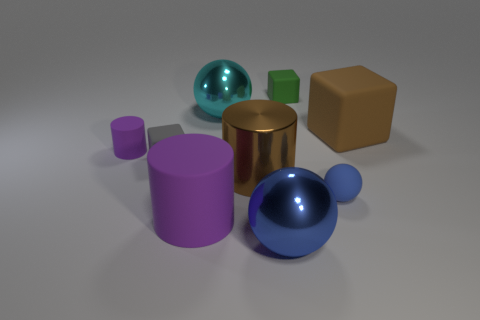There is a purple thing in front of the tiny sphere; is it the same shape as the big brown object that is in front of the small purple matte cylinder?
Offer a terse response. Yes. Is the material of the cube in front of the small rubber cylinder the same as the large sphere that is behind the tiny matte cylinder?
Your answer should be compact. No. What is the material of the brown thing that is on the right side of the blue object that is right of the green rubber block?
Provide a short and direct response. Rubber. What shape is the shiny object that is behind the small matte cube in front of the ball behind the tiny gray rubber thing?
Provide a succinct answer. Sphere. There is another large object that is the same shape as the cyan object; what material is it?
Provide a short and direct response. Metal. What number of tiny yellow spheres are there?
Give a very brief answer. 0. What is the shape of the large brown object that is right of the tiny green block?
Provide a succinct answer. Cube. The big matte thing that is on the left side of the blue thing that is on the left side of the blue ball that is to the right of the green rubber thing is what color?
Give a very brief answer. Purple. There is a small blue object that is made of the same material as the big purple object; what shape is it?
Ensure brevity in your answer.  Sphere. Are there fewer tiny purple cylinders than small blue cylinders?
Provide a short and direct response. No. 